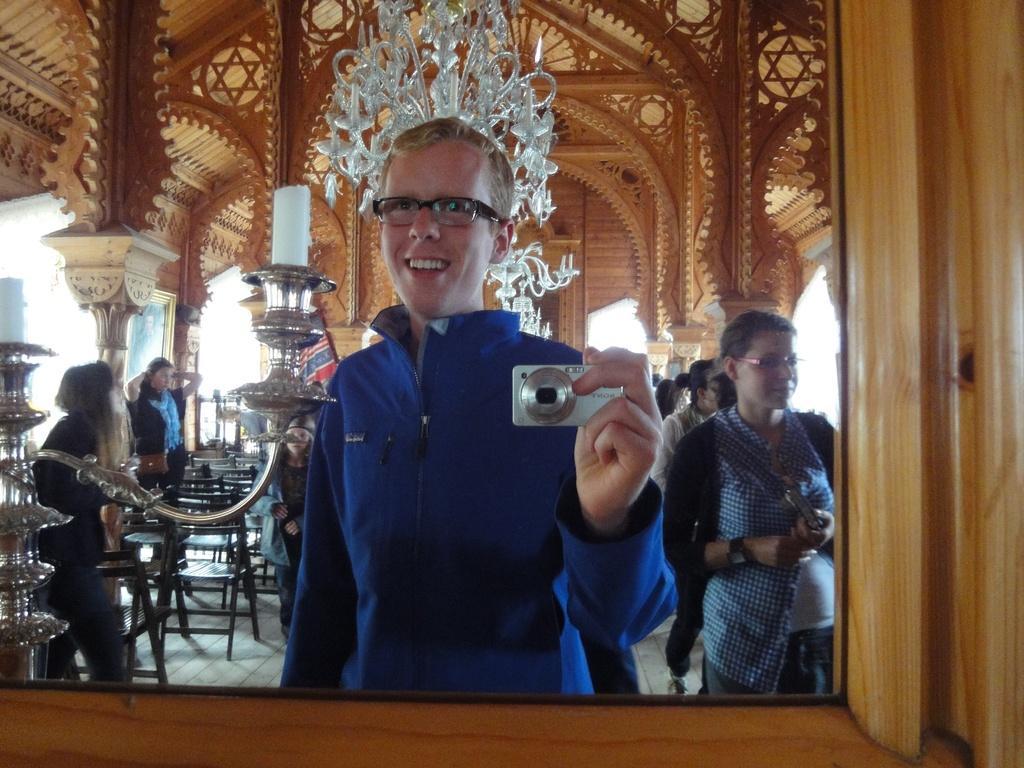Could you give a brief overview of what you see in this image? In this picture we can see a group of people on the floor and a man wore spectacles and holding a camera with his hand and at the back of him we can see a stand, candles, chairs, frame, cloth and some objects. 